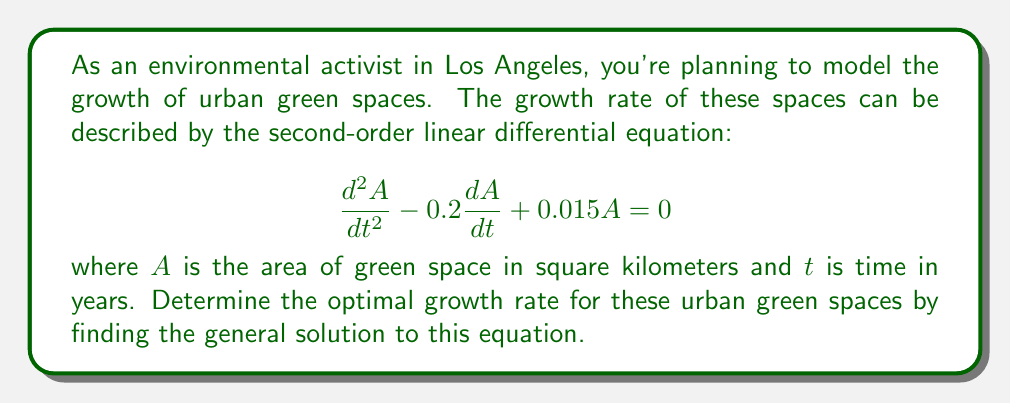Show me your answer to this math problem. To solve this second-order linear differential equation, we'll follow these steps:

1) First, we need to find the characteristic equation. For a second-order linear differential equation in the form:

   $$a\frac{d^2y}{dx^2} + b\frac{dy}{dx} + cy = 0$$

   The characteristic equation is:

   $$ar^2 + br + c = 0$$

2) In our case, $a=1$, $b=-0.2$, and $c=0.015$. So our characteristic equation is:

   $$r^2 - 0.2r + 0.015 = 0$$

3) We can solve this quadratic equation using the quadratic formula:

   $$r = \frac{-b \pm \sqrt{b^2 - 4ac}}{2a}$$

4) Substituting our values:

   $$r = \frac{0.2 \pm \sqrt{0.2^2 - 4(1)(0.015)}}{2(1)}$$

   $$r = \frac{0.2 \pm \sqrt{0.04 - 0.06}}{2}$$

   $$r = \frac{0.2 \pm \sqrt{-0.02}}{2}$$

5) This gives us complex roots:

   $$r = 0.1 \pm 0.1i$$

6) The general solution for complex roots $a \pm bi$ is:

   $$y = e^{at}(c_1\cos(bt) + c_2\sin(bt))$$

7) Therefore, our general solution is:

   $$A(t) = e^{0.1t}(c_1\cos(0.1t) + c_2\sin(0.1t))$$

Where $c_1$ and $c_2$ are arbitrary constants determined by initial conditions.

This solution represents the optimal growth rate for the urban green spaces over time.
Answer: $A(t) = e^{0.1t}(c_1\cos(0.1t) + c_2\sin(0.1t))$, where $c_1$ and $c_2$ are constants determined by initial conditions. 